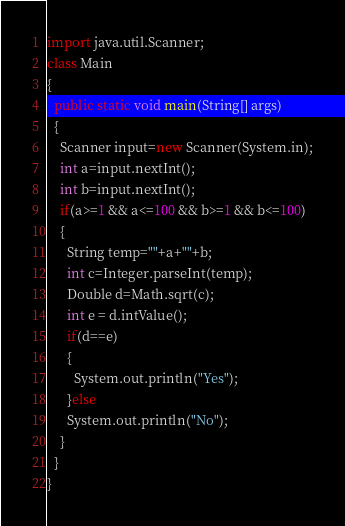<code> <loc_0><loc_0><loc_500><loc_500><_Java_>import java.util.Scanner;
class Main 
{
  public static void main(String[] args) 
  {
    Scanner input=new Scanner(System.in);
    int a=input.nextInt();
    int b=input.nextInt();
    if(a>=1 && a<=100 && b>=1 && b<=100)
    {
      String temp=""+a+""+b;
      int c=Integer.parseInt(temp);
      Double d=Math.sqrt(c);
      int e = d.intValue();
      if(d==e)
      {
        System.out.println("Yes");
      }else
      System.out.println("No");
    }
  }
}</code> 